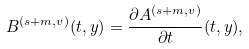Convert formula to latex. <formula><loc_0><loc_0><loc_500><loc_500>B ^ { ( s + m , v ) } ( t , y ) = \frac { \partial A ^ { ( s + m , v ) } } { \partial t } ( t , y ) ,</formula> 